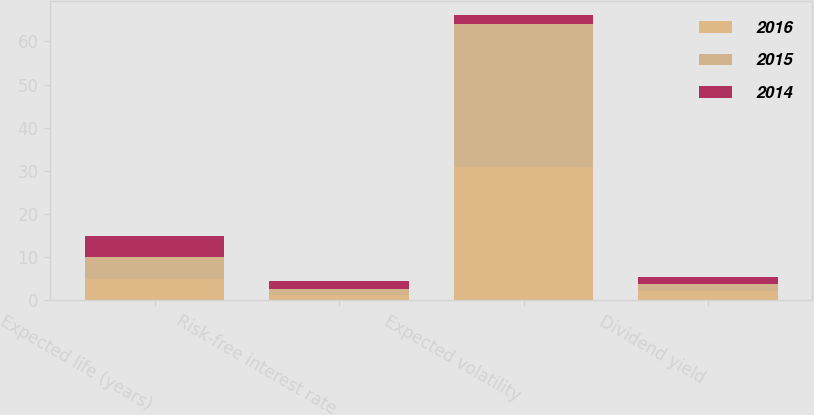Convert chart. <chart><loc_0><loc_0><loc_500><loc_500><stacked_bar_chart><ecel><fcel>Expected life (years)<fcel>Risk-free interest rate<fcel>Expected volatility<fcel>Dividend yield<nl><fcel>2016<fcel>5<fcel>1.34<fcel>30.96<fcel>2.1<nl><fcel>2015<fcel>5<fcel>1.41<fcel>33.06<fcel>1.69<nl><fcel>2014<fcel>5<fcel>1.8<fcel>2.1<fcel>1.61<nl></chart> 